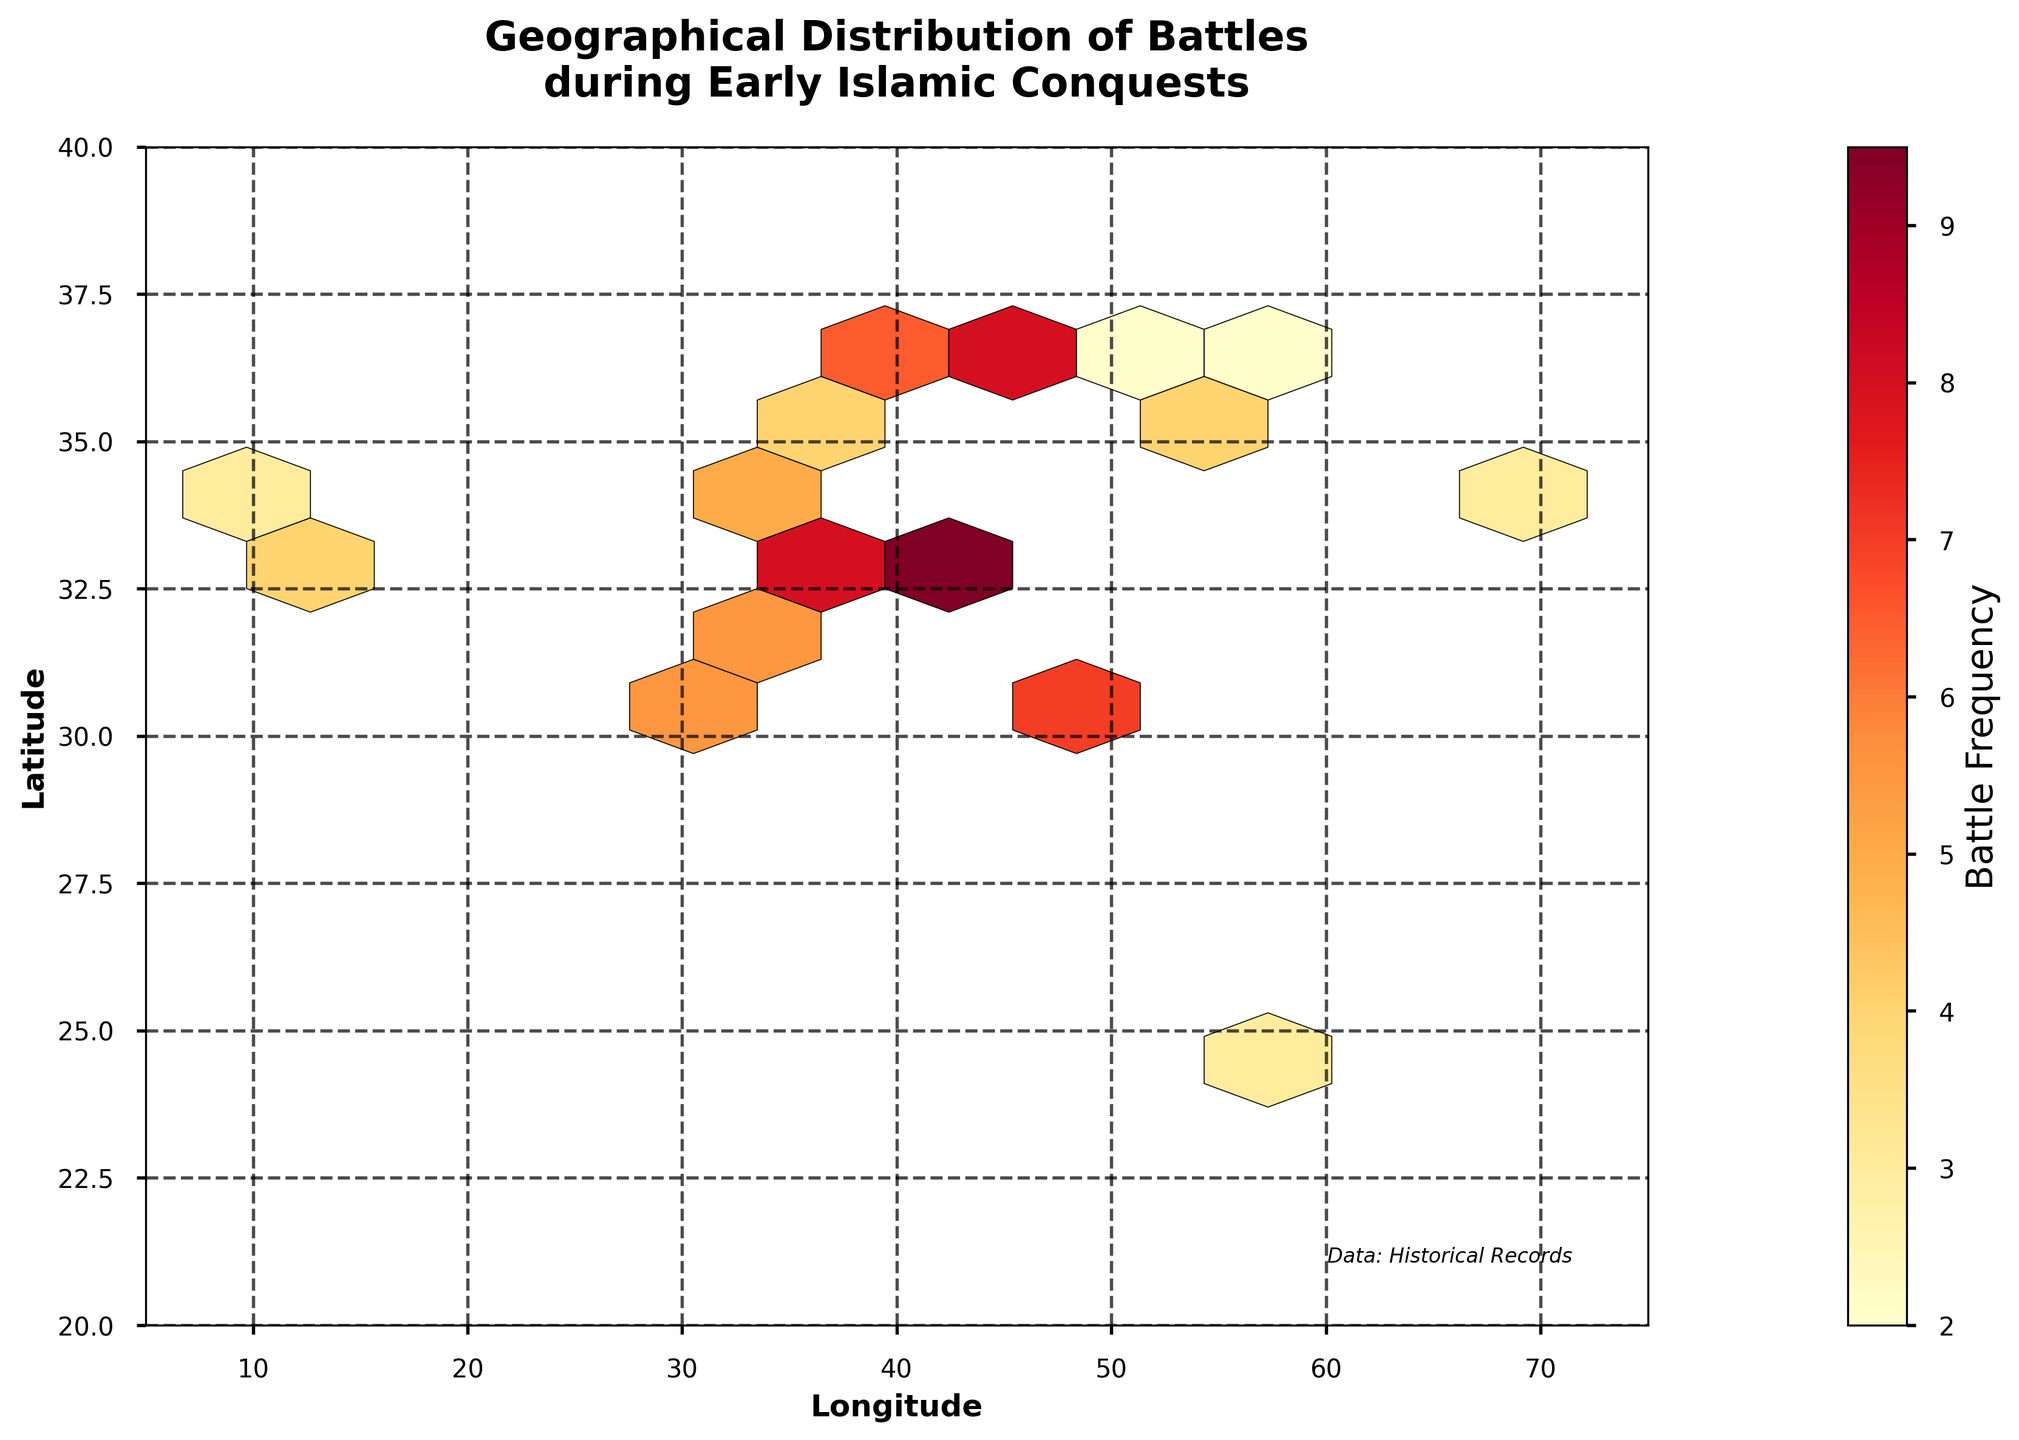What is the title of the figure? The title of the figure is displayed at the top, which provides an overall description of the represented data. The title reads "Geographical Distribution of Battles during Early Islamic Conquests".
Answer: Geographical Distribution of Battles during Early Islamic Conquests What are the axis labels in the figure? The axis labels are written along the two axes to denote what each axis represents. The x-axis is labeled "Longitude," and the y-axis is labeled "Latitude".
Answer: Longitude (x-axis), Latitude (y-axis) What color scheme is used for the hexagons in the plot and what does it represent? The color scheme ranges from lighter to darker shades of yellow to red, representing different frequencies of battles. Darker shades indicate a higher frequency of battles.
Answer: Yellow to red color scheme Where are the areas of highest frequency of battles located geographically? The areas with the darkest shades (indicating the highest frequencies) can be identified by their coordinates. Notably, at coordinates around (33.3, 44.4).
Answer: Around (33.3, 44.4) Which region had more battles, around coordinates (31.2, 29.9) or (35.9, 39.9)? To determine which region had more battles, compare the colors of the hexagons at these coordinates. The region around (31.2, 29.9) shows a darker hexagon.
Answer: Around (31.2, 29.9) What is the range of longitudes covered in the plot? The range of longitudes is denoted by the x-axis ticks, which spans from approximately 5 to 75 degrees.
Answer: Approximately 5 to 75 degrees What additional information is provided at the bottom right of the plot? There is a text annotation at the bottom right of the plot that mentions the source of the data. It says, "Data: Historical Records".
Answer: Data: Historical Records Comparing latitudes, which region had more battles: the one around (36.2, 37.2) or the one around (30.3, 47.8)? By analyzing the hexagon colors at these coordinates, the region around (30.3, 47.8) is darker, indicating more battles.
Answer: Around (30.3, 47.8) Which geographical region had the fewest battles, and what is its frequency based on the plot? Inspect the lightest-colored hexagons, which indicate the lowest frequency of battles. The region around coordinates (36.2, 59.6) is one of the lightest and the frequency is 2.
Answer: Around (36.2, 59.6) with frequency 2 What is the total possible range of battle frequencies indicated by the color bar? The color bar shows the gradient representation of battle frequencies, ranging from the lightest shade indicating the least frequency to the darkest for the highest frequency. The numbers on the color bar range from 0 to 10.
Answer: 0 to 10 